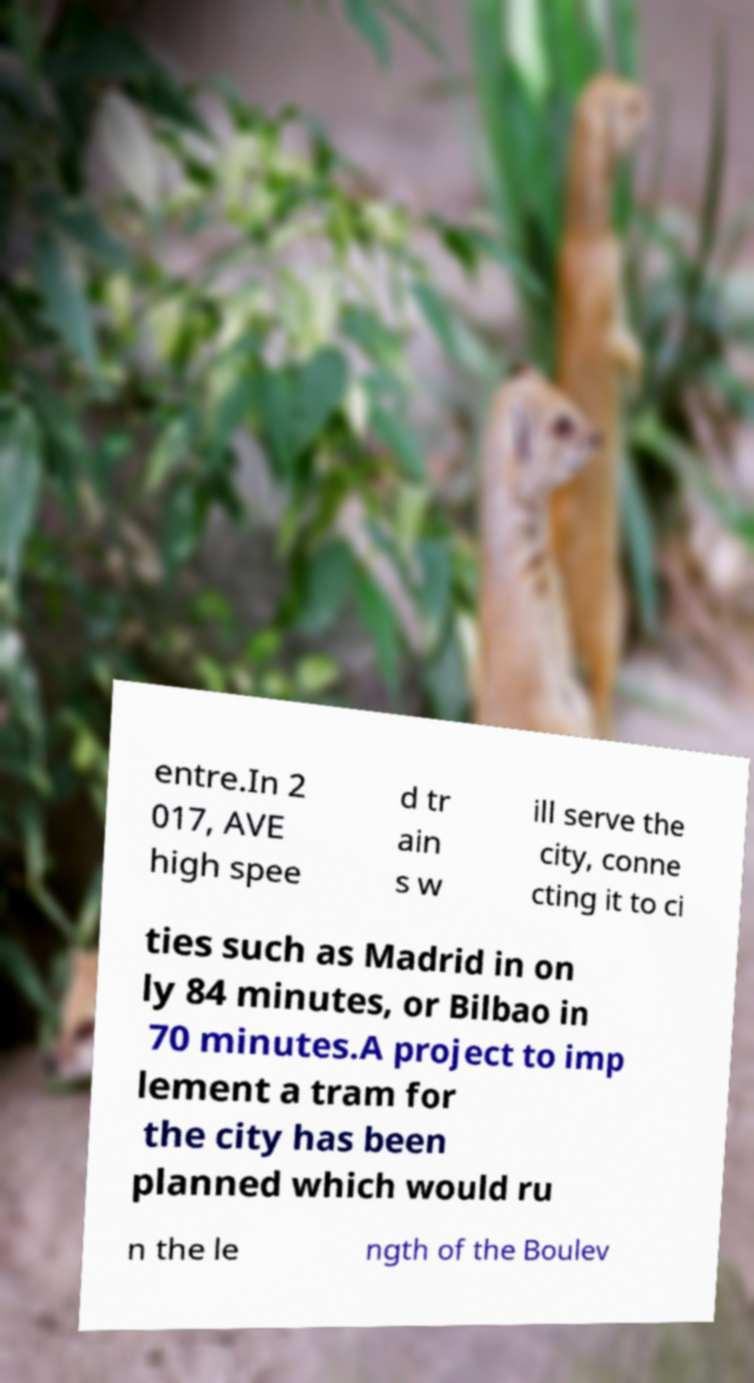Please read and relay the text visible in this image. What does it say? entre.In 2 017, AVE high spee d tr ain s w ill serve the city, conne cting it to ci ties such as Madrid in on ly 84 minutes, or Bilbao in 70 minutes.A project to imp lement a tram for the city has been planned which would ru n the le ngth of the Boulev 